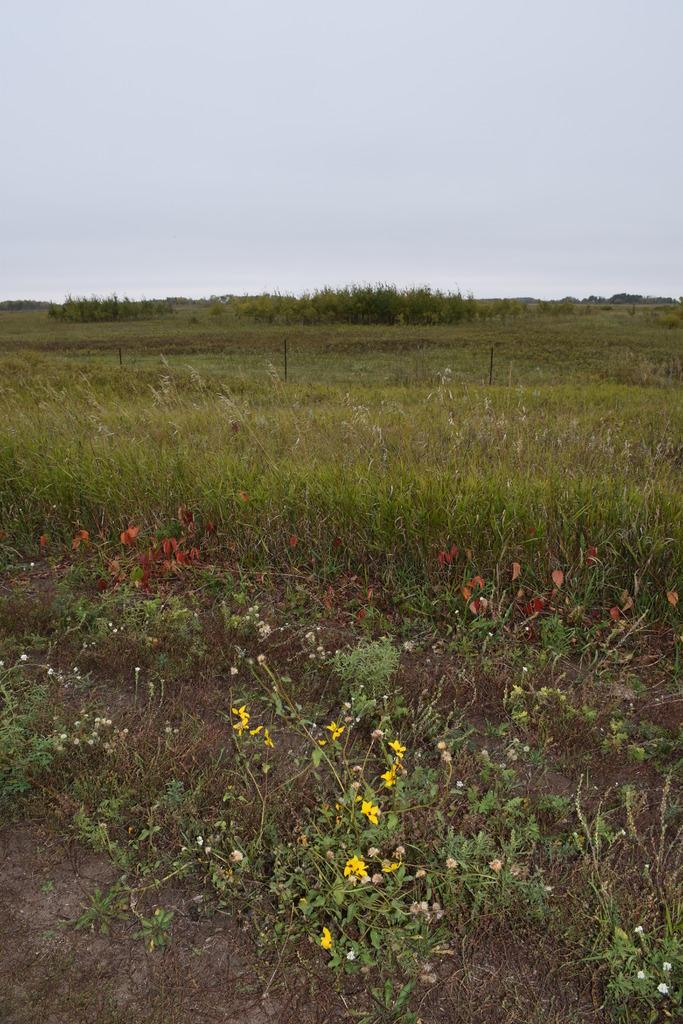What type of vegetation can be seen on the ground in the image? There are many plants on the ground in the image. What specific type of plant can be seen in the image? There are flowers in the image. What can be seen in the background of the image? The sky is visible in the background of the image. What historical event is being commemorated by the flowers in the image? There is no indication of a historical event being commemorated in the image; it simply features plants and flowers on the ground. 